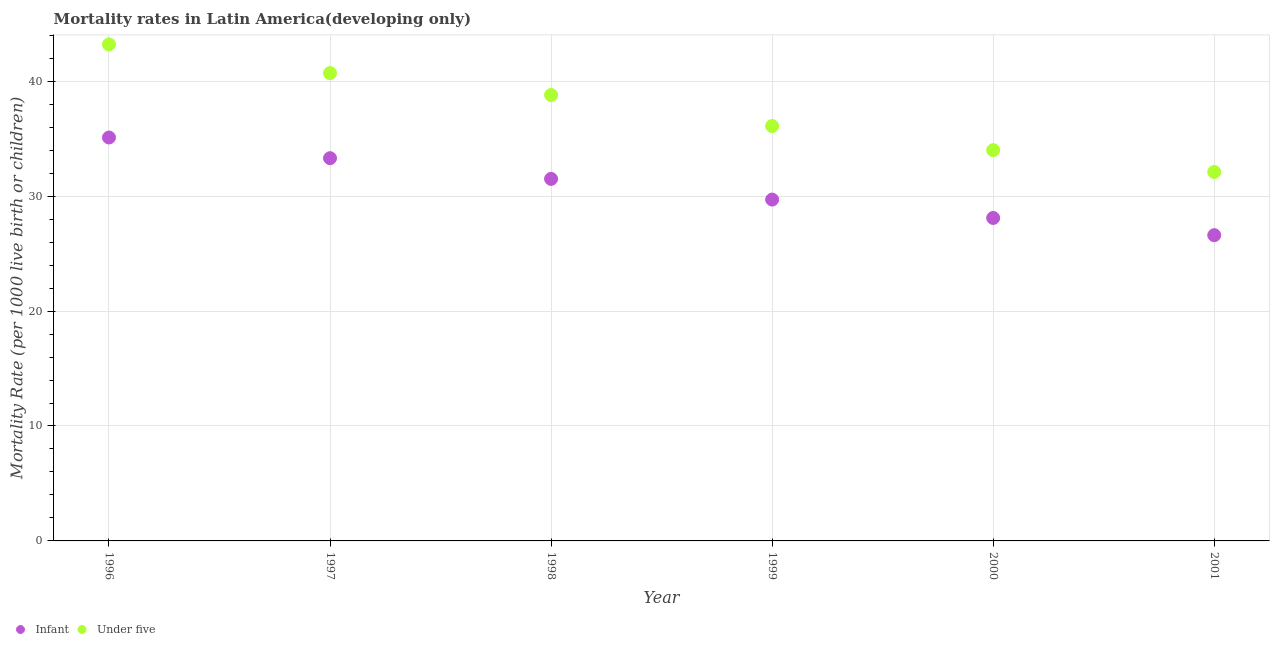How many different coloured dotlines are there?
Give a very brief answer. 2. What is the under-5 mortality rate in 2001?
Give a very brief answer. 32.1. Across all years, what is the maximum under-5 mortality rate?
Make the answer very short. 43.2. Across all years, what is the minimum under-5 mortality rate?
Provide a succinct answer. 32.1. What is the total under-5 mortality rate in the graph?
Offer a terse response. 224.9. What is the difference between the infant mortality rate in 2000 and that in 2001?
Provide a short and direct response. 1.5. What is the average infant mortality rate per year?
Your answer should be compact. 30.72. In the year 1999, what is the difference between the under-5 mortality rate and infant mortality rate?
Your answer should be compact. 6.4. What is the ratio of the infant mortality rate in 1996 to that in 2000?
Make the answer very short. 1.25. Is the infant mortality rate in 1998 less than that in 1999?
Offer a very short reply. No. Is the difference between the infant mortality rate in 1998 and 1999 greater than the difference between the under-5 mortality rate in 1998 and 1999?
Your response must be concise. No. What is the difference between the highest and the second highest infant mortality rate?
Make the answer very short. 1.8. Is the sum of the infant mortality rate in 1997 and 1999 greater than the maximum under-5 mortality rate across all years?
Give a very brief answer. Yes. Does the infant mortality rate monotonically increase over the years?
Provide a succinct answer. No. Is the infant mortality rate strictly less than the under-5 mortality rate over the years?
Offer a very short reply. Yes. How many dotlines are there?
Offer a terse response. 2. What is the difference between two consecutive major ticks on the Y-axis?
Give a very brief answer. 10. Are the values on the major ticks of Y-axis written in scientific E-notation?
Your response must be concise. No. How are the legend labels stacked?
Provide a short and direct response. Horizontal. What is the title of the graph?
Your response must be concise. Mortality rates in Latin America(developing only). What is the label or title of the Y-axis?
Provide a succinct answer. Mortality Rate (per 1000 live birth or children). What is the Mortality Rate (per 1000 live birth or children) in Infant in 1996?
Provide a succinct answer. 35.1. What is the Mortality Rate (per 1000 live birth or children) of Under five in 1996?
Your answer should be very brief. 43.2. What is the Mortality Rate (per 1000 live birth or children) in Infant in 1997?
Make the answer very short. 33.3. What is the Mortality Rate (per 1000 live birth or children) in Under five in 1997?
Offer a terse response. 40.7. What is the Mortality Rate (per 1000 live birth or children) of Infant in 1998?
Ensure brevity in your answer.  31.5. What is the Mortality Rate (per 1000 live birth or children) in Under five in 1998?
Your answer should be very brief. 38.8. What is the Mortality Rate (per 1000 live birth or children) of Infant in 1999?
Make the answer very short. 29.7. What is the Mortality Rate (per 1000 live birth or children) of Under five in 1999?
Provide a short and direct response. 36.1. What is the Mortality Rate (per 1000 live birth or children) in Infant in 2000?
Provide a succinct answer. 28.1. What is the Mortality Rate (per 1000 live birth or children) in Infant in 2001?
Provide a short and direct response. 26.6. What is the Mortality Rate (per 1000 live birth or children) in Under five in 2001?
Make the answer very short. 32.1. Across all years, what is the maximum Mortality Rate (per 1000 live birth or children) of Infant?
Keep it short and to the point. 35.1. Across all years, what is the maximum Mortality Rate (per 1000 live birth or children) of Under five?
Provide a short and direct response. 43.2. Across all years, what is the minimum Mortality Rate (per 1000 live birth or children) in Infant?
Make the answer very short. 26.6. Across all years, what is the minimum Mortality Rate (per 1000 live birth or children) in Under five?
Your answer should be very brief. 32.1. What is the total Mortality Rate (per 1000 live birth or children) in Infant in the graph?
Your response must be concise. 184.3. What is the total Mortality Rate (per 1000 live birth or children) of Under five in the graph?
Provide a succinct answer. 224.9. What is the difference between the Mortality Rate (per 1000 live birth or children) in Infant in 1996 and that in 1997?
Your response must be concise. 1.8. What is the difference between the Mortality Rate (per 1000 live birth or children) of Under five in 1996 and that in 1997?
Offer a very short reply. 2.5. What is the difference between the Mortality Rate (per 1000 live birth or children) in Infant in 1996 and that in 2000?
Offer a very short reply. 7. What is the difference between the Mortality Rate (per 1000 live birth or children) in Infant in 1997 and that in 1998?
Your answer should be compact. 1.8. What is the difference between the Mortality Rate (per 1000 live birth or children) of Infant in 1997 and that in 1999?
Provide a short and direct response. 3.6. What is the difference between the Mortality Rate (per 1000 live birth or children) in Under five in 1997 and that in 1999?
Offer a very short reply. 4.6. What is the difference between the Mortality Rate (per 1000 live birth or children) of Infant in 1997 and that in 2000?
Provide a short and direct response. 5.2. What is the difference between the Mortality Rate (per 1000 live birth or children) in Under five in 1997 and that in 2001?
Offer a very short reply. 8.6. What is the difference between the Mortality Rate (per 1000 live birth or children) in Under five in 1998 and that in 1999?
Provide a succinct answer. 2.7. What is the difference between the Mortality Rate (per 1000 live birth or children) in Infant in 1998 and that in 2000?
Your response must be concise. 3.4. What is the difference between the Mortality Rate (per 1000 live birth or children) in Under five in 1998 and that in 2000?
Provide a short and direct response. 4.8. What is the difference between the Mortality Rate (per 1000 live birth or children) in Infant in 1998 and that in 2001?
Your answer should be very brief. 4.9. What is the difference between the Mortality Rate (per 1000 live birth or children) in Under five in 1998 and that in 2001?
Offer a terse response. 6.7. What is the difference between the Mortality Rate (per 1000 live birth or children) in Infant in 1999 and that in 2000?
Offer a very short reply. 1.6. What is the difference between the Mortality Rate (per 1000 live birth or children) of Infant in 1999 and that in 2001?
Your answer should be very brief. 3.1. What is the difference between the Mortality Rate (per 1000 live birth or children) of Infant in 1996 and the Mortality Rate (per 1000 live birth or children) of Under five in 1997?
Keep it short and to the point. -5.6. What is the difference between the Mortality Rate (per 1000 live birth or children) of Infant in 1996 and the Mortality Rate (per 1000 live birth or children) of Under five in 1998?
Offer a terse response. -3.7. What is the difference between the Mortality Rate (per 1000 live birth or children) of Infant in 1996 and the Mortality Rate (per 1000 live birth or children) of Under five in 1999?
Your answer should be compact. -1. What is the difference between the Mortality Rate (per 1000 live birth or children) in Infant in 1996 and the Mortality Rate (per 1000 live birth or children) in Under five in 2000?
Offer a terse response. 1.1. What is the difference between the Mortality Rate (per 1000 live birth or children) of Infant in 1996 and the Mortality Rate (per 1000 live birth or children) of Under five in 2001?
Ensure brevity in your answer.  3. What is the difference between the Mortality Rate (per 1000 live birth or children) of Infant in 1997 and the Mortality Rate (per 1000 live birth or children) of Under five in 1999?
Provide a succinct answer. -2.8. What is the difference between the Mortality Rate (per 1000 live birth or children) of Infant in 1999 and the Mortality Rate (per 1000 live birth or children) of Under five in 2000?
Keep it short and to the point. -4.3. What is the difference between the Mortality Rate (per 1000 live birth or children) of Infant in 1999 and the Mortality Rate (per 1000 live birth or children) of Under five in 2001?
Keep it short and to the point. -2.4. What is the difference between the Mortality Rate (per 1000 live birth or children) of Infant in 2000 and the Mortality Rate (per 1000 live birth or children) of Under five in 2001?
Give a very brief answer. -4. What is the average Mortality Rate (per 1000 live birth or children) of Infant per year?
Provide a short and direct response. 30.72. What is the average Mortality Rate (per 1000 live birth or children) of Under five per year?
Provide a succinct answer. 37.48. In the year 1996, what is the difference between the Mortality Rate (per 1000 live birth or children) in Infant and Mortality Rate (per 1000 live birth or children) in Under five?
Your answer should be compact. -8.1. In the year 1998, what is the difference between the Mortality Rate (per 1000 live birth or children) of Infant and Mortality Rate (per 1000 live birth or children) of Under five?
Your answer should be compact. -7.3. What is the ratio of the Mortality Rate (per 1000 live birth or children) in Infant in 1996 to that in 1997?
Your answer should be compact. 1.05. What is the ratio of the Mortality Rate (per 1000 live birth or children) in Under five in 1996 to that in 1997?
Provide a succinct answer. 1.06. What is the ratio of the Mortality Rate (per 1000 live birth or children) in Infant in 1996 to that in 1998?
Ensure brevity in your answer.  1.11. What is the ratio of the Mortality Rate (per 1000 live birth or children) of Under five in 1996 to that in 1998?
Your answer should be very brief. 1.11. What is the ratio of the Mortality Rate (per 1000 live birth or children) in Infant in 1996 to that in 1999?
Offer a terse response. 1.18. What is the ratio of the Mortality Rate (per 1000 live birth or children) of Under five in 1996 to that in 1999?
Provide a short and direct response. 1.2. What is the ratio of the Mortality Rate (per 1000 live birth or children) of Infant in 1996 to that in 2000?
Provide a succinct answer. 1.25. What is the ratio of the Mortality Rate (per 1000 live birth or children) of Under five in 1996 to that in 2000?
Offer a very short reply. 1.27. What is the ratio of the Mortality Rate (per 1000 live birth or children) of Infant in 1996 to that in 2001?
Provide a short and direct response. 1.32. What is the ratio of the Mortality Rate (per 1000 live birth or children) of Under five in 1996 to that in 2001?
Offer a very short reply. 1.35. What is the ratio of the Mortality Rate (per 1000 live birth or children) of Infant in 1997 to that in 1998?
Offer a very short reply. 1.06. What is the ratio of the Mortality Rate (per 1000 live birth or children) in Under five in 1997 to that in 1998?
Give a very brief answer. 1.05. What is the ratio of the Mortality Rate (per 1000 live birth or children) in Infant in 1997 to that in 1999?
Your answer should be compact. 1.12. What is the ratio of the Mortality Rate (per 1000 live birth or children) of Under five in 1997 to that in 1999?
Make the answer very short. 1.13. What is the ratio of the Mortality Rate (per 1000 live birth or children) in Infant in 1997 to that in 2000?
Your answer should be very brief. 1.19. What is the ratio of the Mortality Rate (per 1000 live birth or children) of Under five in 1997 to that in 2000?
Your response must be concise. 1.2. What is the ratio of the Mortality Rate (per 1000 live birth or children) of Infant in 1997 to that in 2001?
Offer a terse response. 1.25. What is the ratio of the Mortality Rate (per 1000 live birth or children) in Under five in 1997 to that in 2001?
Make the answer very short. 1.27. What is the ratio of the Mortality Rate (per 1000 live birth or children) of Infant in 1998 to that in 1999?
Ensure brevity in your answer.  1.06. What is the ratio of the Mortality Rate (per 1000 live birth or children) in Under five in 1998 to that in 1999?
Offer a very short reply. 1.07. What is the ratio of the Mortality Rate (per 1000 live birth or children) of Infant in 1998 to that in 2000?
Offer a very short reply. 1.12. What is the ratio of the Mortality Rate (per 1000 live birth or children) in Under five in 1998 to that in 2000?
Ensure brevity in your answer.  1.14. What is the ratio of the Mortality Rate (per 1000 live birth or children) of Infant in 1998 to that in 2001?
Your answer should be very brief. 1.18. What is the ratio of the Mortality Rate (per 1000 live birth or children) in Under five in 1998 to that in 2001?
Provide a short and direct response. 1.21. What is the ratio of the Mortality Rate (per 1000 live birth or children) in Infant in 1999 to that in 2000?
Give a very brief answer. 1.06. What is the ratio of the Mortality Rate (per 1000 live birth or children) in Under five in 1999 to that in 2000?
Keep it short and to the point. 1.06. What is the ratio of the Mortality Rate (per 1000 live birth or children) of Infant in 1999 to that in 2001?
Your response must be concise. 1.12. What is the ratio of the Mortality Rate (per 1000 live birth or children) in Under five in 1999 to that in 2001?
Your response must be concise. 1.12. What is the ratio of the Mortality Rate (per 1000 live birth or children) of Infant in 2000 to that in 2001?
Your answer should be compact. 1.06. What is the ratio of the Mortality Rate (per 1000 live birth or children) in Under five in 2000 to that in 2001?
Provide a succinct answer. 1.06. What is the difference between the highest and the lowest Mortality Rate (per 1000 live birth or children) of Infant?
Offer a terse response. 8.5. 